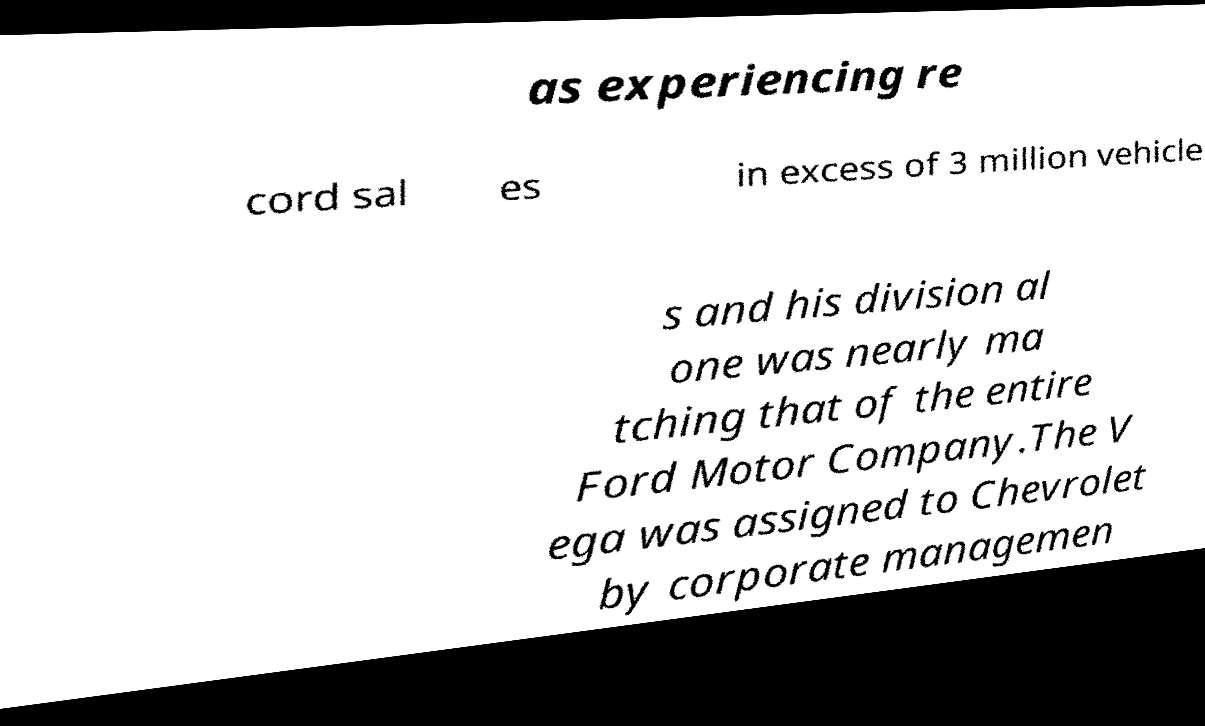There's text embedded in this image that I need extracted. Can you transcribe it verbatim? as experiencing re cord sal es in excess of 3 million vehicle s and his division al one was nearly ma tching that of the entire Ford Motor Company.The V ega was assigned to Chevrolet by corporate managemen 